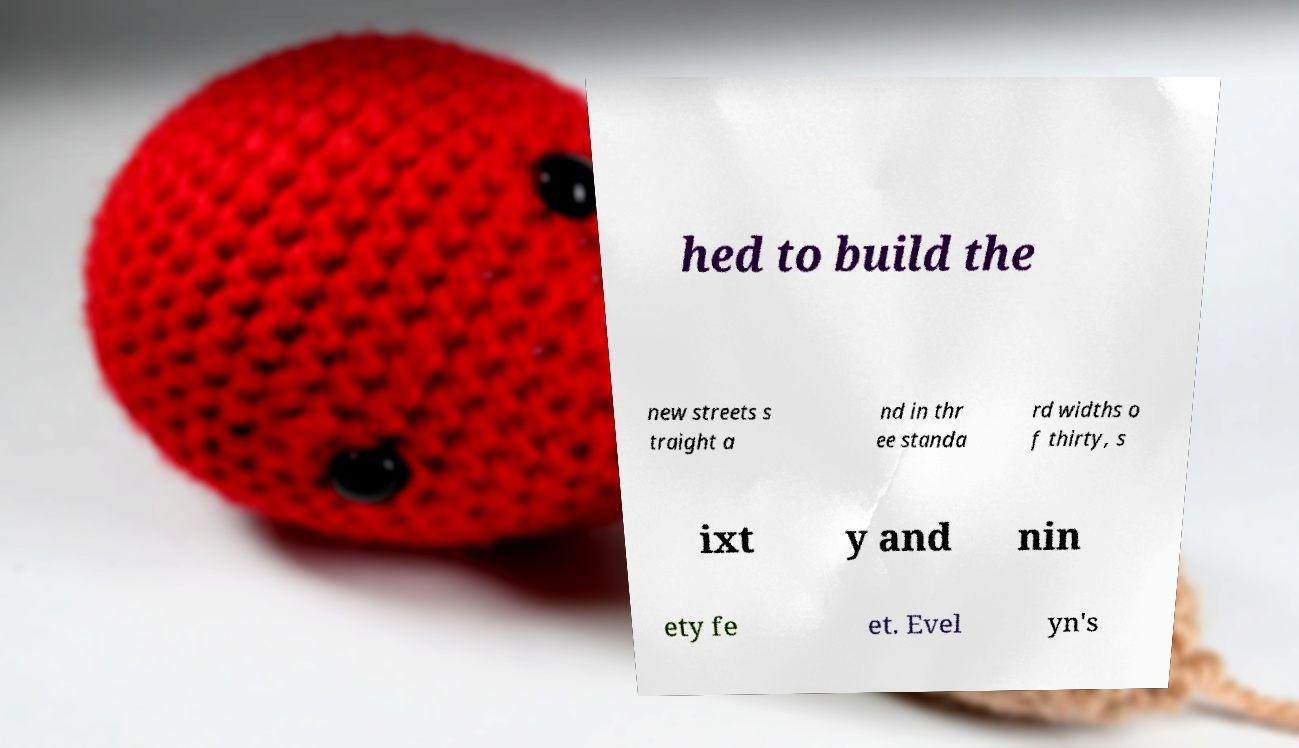There's text embedded in this image that I need extracted. Can you transcribe it verbatim? hed to build the new streets s traight a nd in thr ee standa rd widths o f thirty, s ixt y and nin ety fe et. Evel yn's 